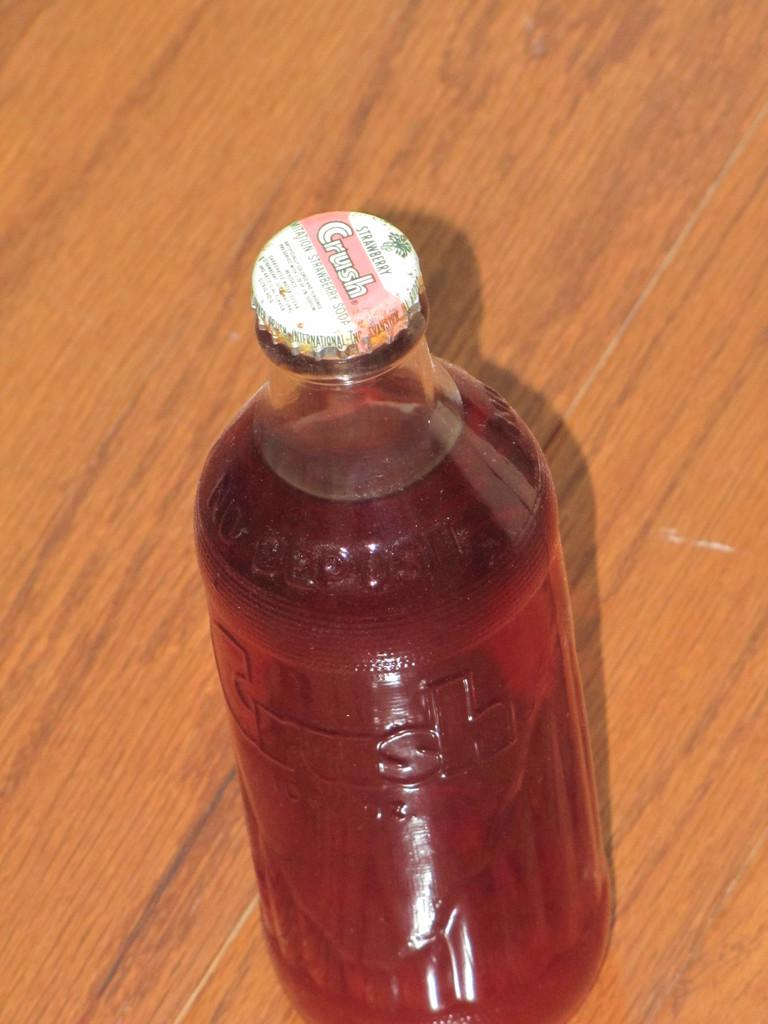Provide a one-sentence caption for the provided image. A bottle of Crush has a metal cap and is sitting on a wooden table. 